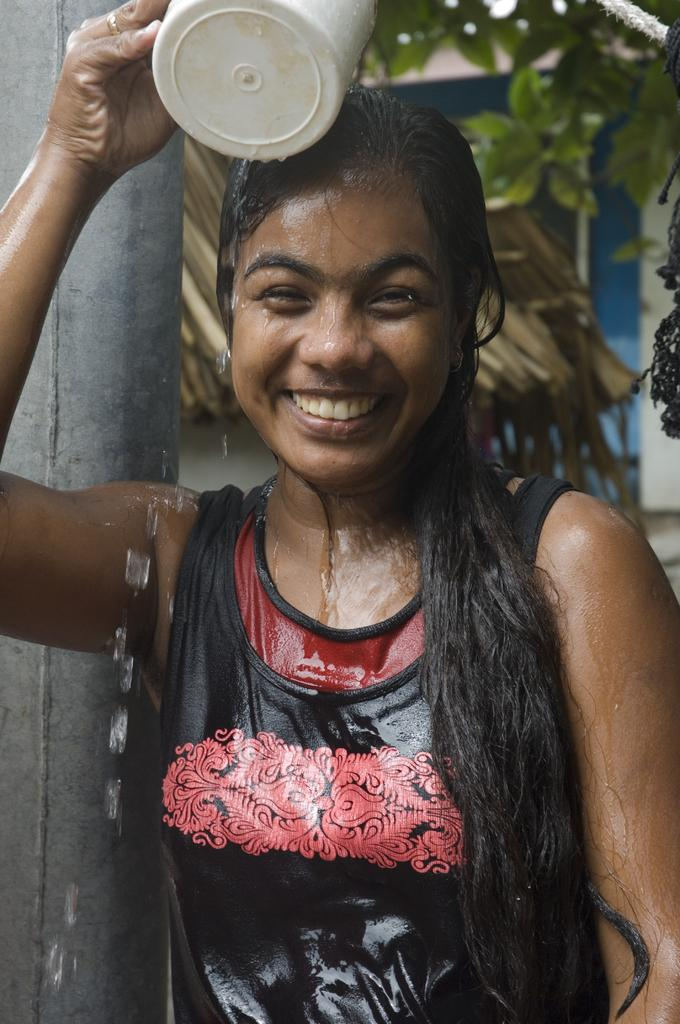What is the main subject of the image? The main subject of the image is a woman. What is the woman doing in the image? The woman is standing and holding a mug of water. How is the woman feeling in the image? The woman is laughing in the image. What can be seen at the left side of the image? There is a pole at the left side of the image. What type of vegetation is present in the image? There is a plant in the image. What is visible in the background of the image? There is a wall in the background of the image. What type of dinosaur can be seen in the image? There are no dinosaurs present in the image. What is the woman using to protect her teeth in the image? The woman is not using anything to protect her teeth in the image, as there is no mention of a fang or any protective device. 